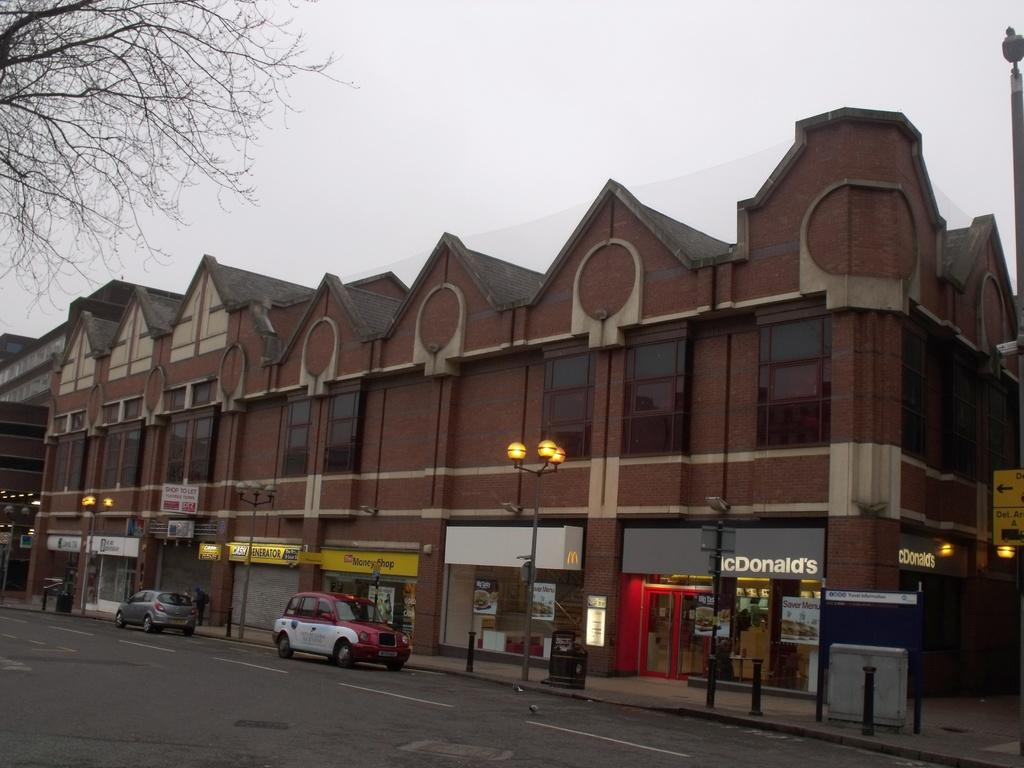<image>
Give a short and clear explanation of the subsequent image. A brown building with multiple business, including a McDonald's. 